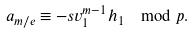<formula> <loc_0><loc_0><loc_500><loc_500>\ a _ { m / e } \equiv - s v _ { 1 } ^ { m - 1 } h _ { 1 } \mod p .</formula> 